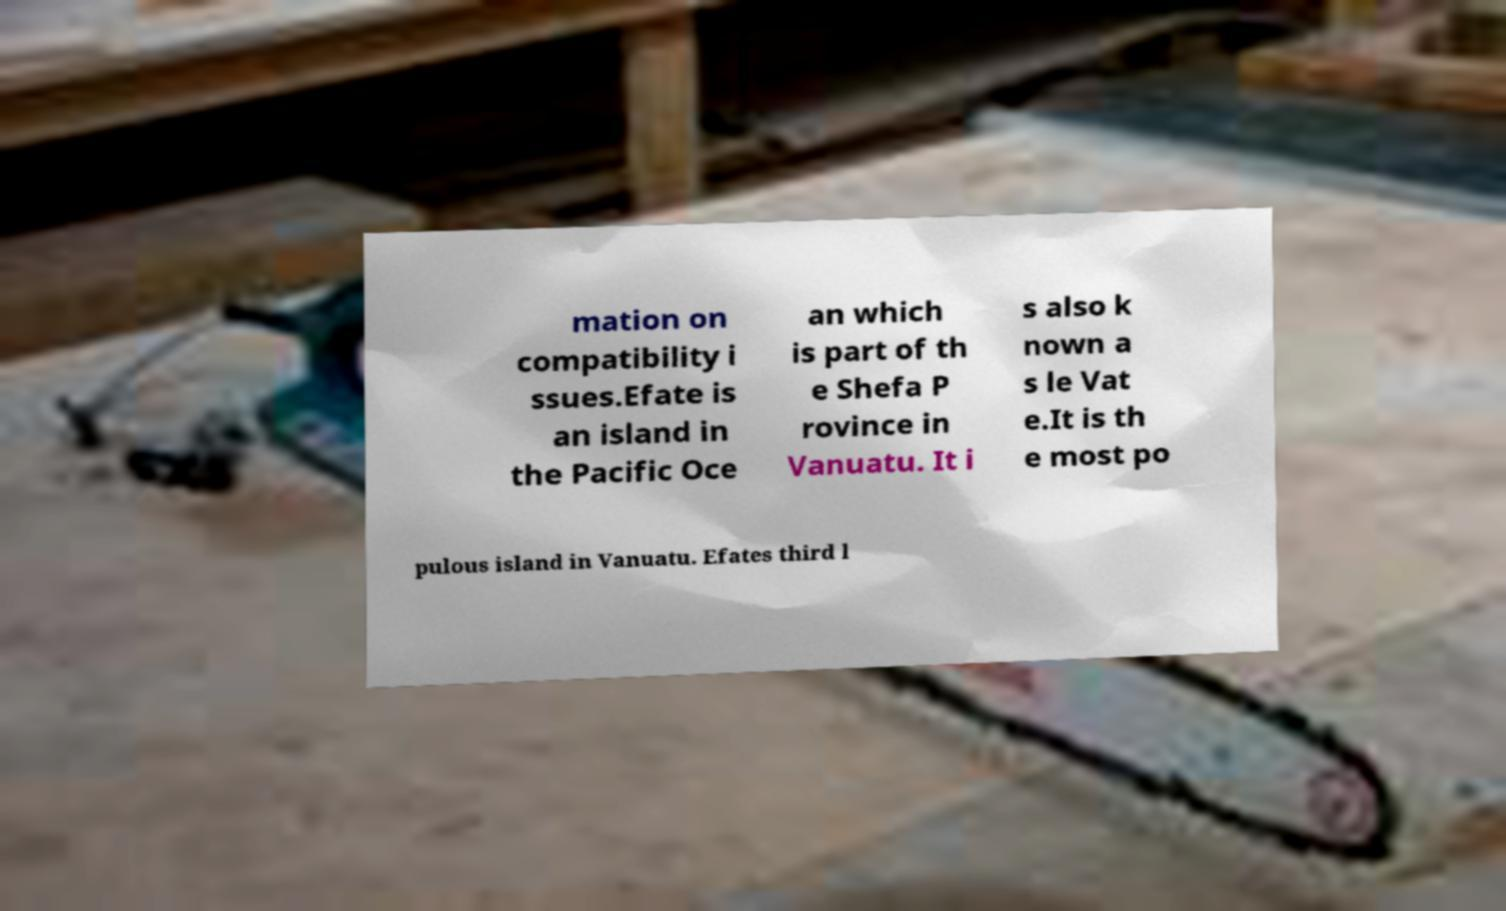There's text embedded in this image that I need extracted. Can you transcribe it verbatim? mation on compatibility i ssues.Efate is an island in the Pacific Oce an which is part of th e Shefa P rovince in Vanuatu. It i s also k nown a s le Vat e.It is th e most po pulous island in Vanuatu. Efates third l 